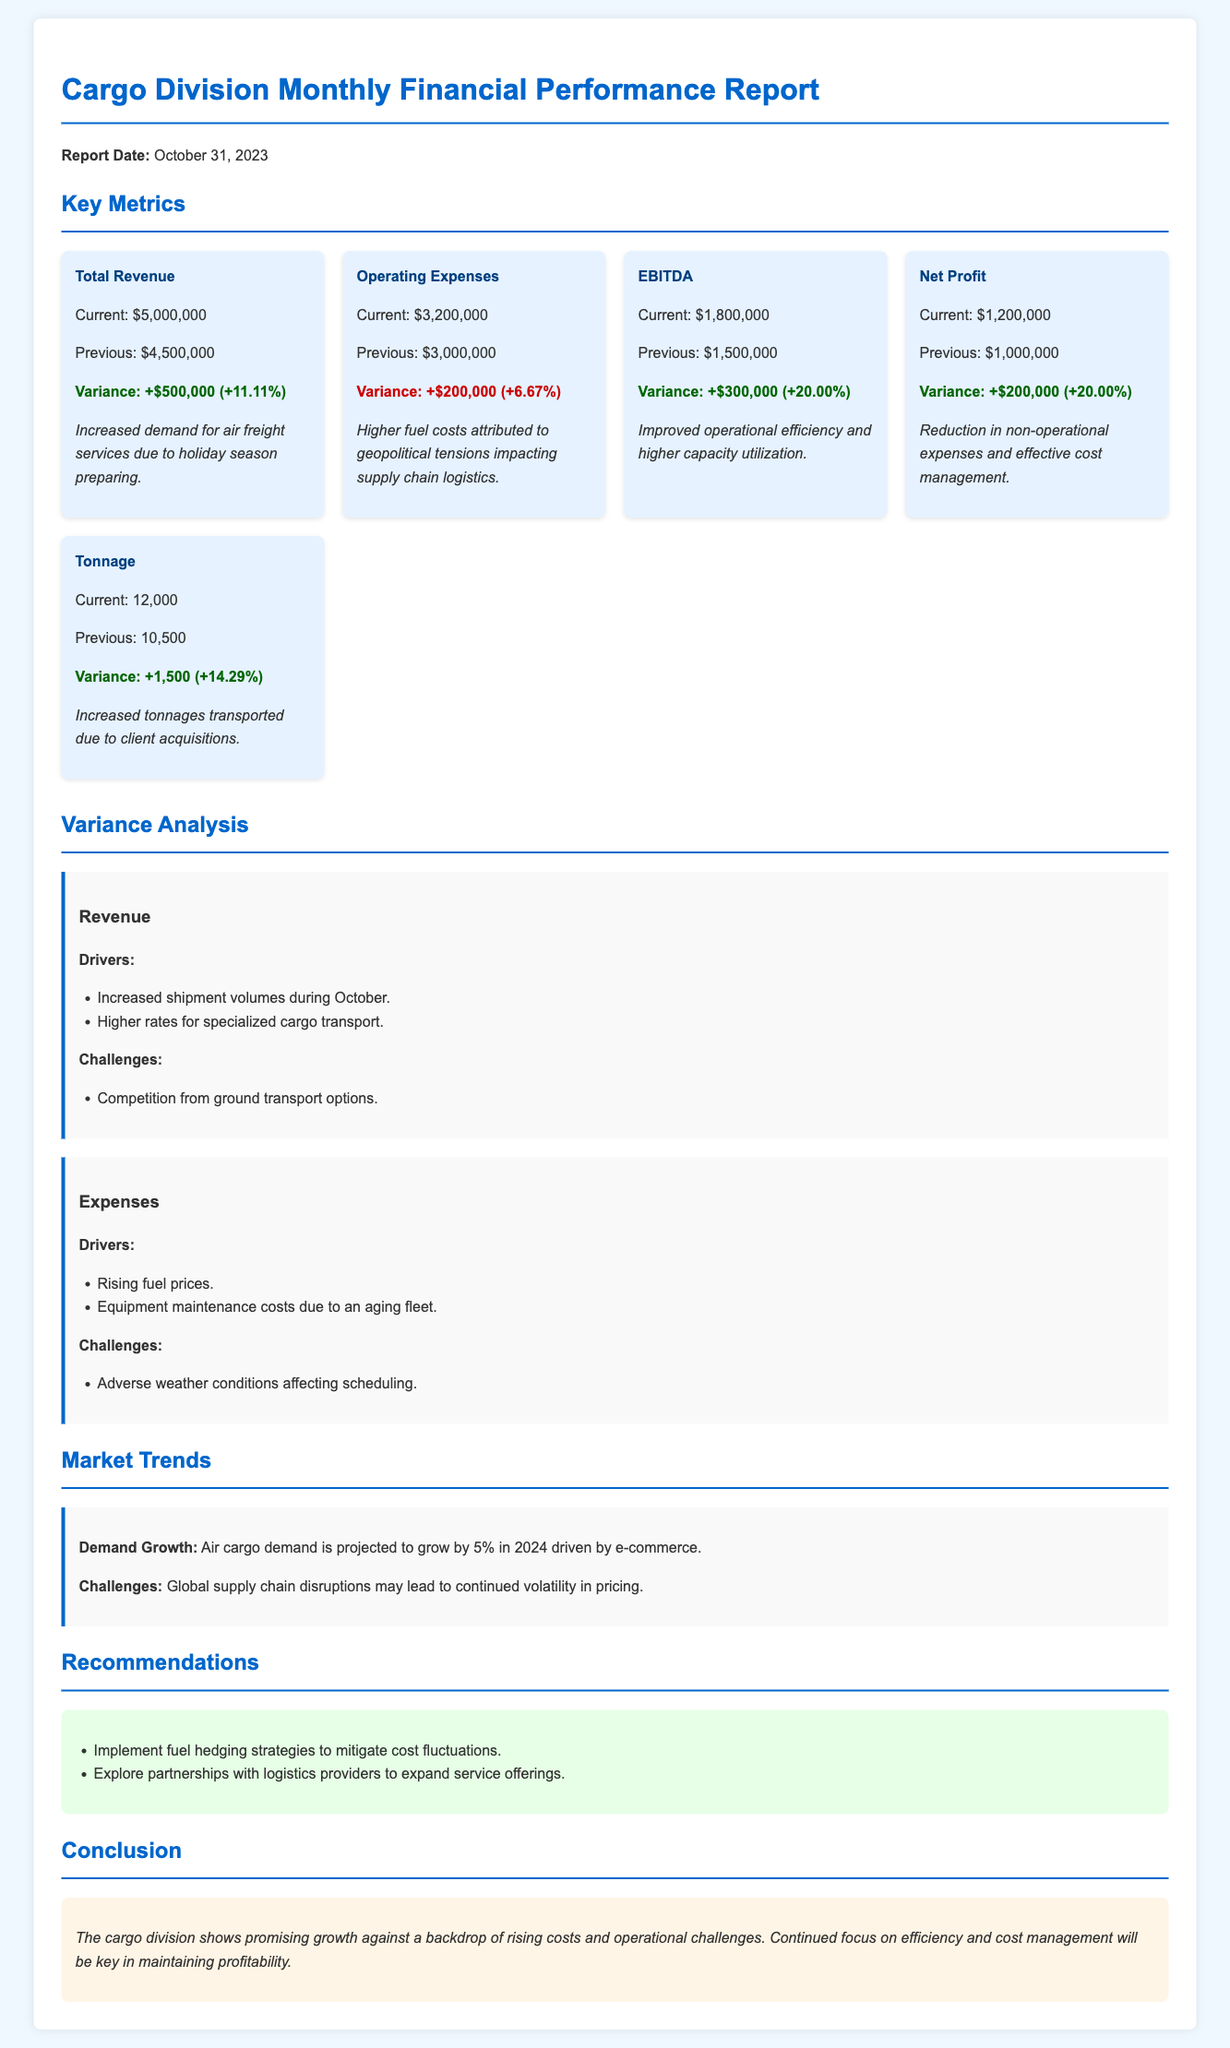what is the total revenue? The total revenue for the cargo division in October 2023, as stated in the document, is $5,000,000.
Answer: $5,000,000 what is the variance for operating expenses? The document shows that operating expenses increased by $200,000 compared to the previous month, which is a variance of +6.67%.
Answer: +$200,000 (+6.67%) what is the current EBITDA? The current EBITDA reported in the document is $1,800,000.
Answer: $1,800,000 what was the previous net profit? According to the document, the previous net profit was $1,000,000.
Answer: $1,000,000 what is the increase in tonnage transported? The document indicates that the tonnage transported increased by 1,500.
Answer: +1,500 what contributed to the increased total revenue? The increase in total revenue was driven by increased shipment volumes and higher rates for specialized cargo transport.
Answer: Increased shipment volumes, higher rates what challenges are mentioned regarding expenses? The document lists adverse weather conditions affecting scheduling as a challenge for expenses.
Answer: Adverse weather conditions what recommendations are provided in the report? The report recommends implementing fuel hedging strategies and exploring partnerships with logistics providers.
Answer: Fuel hedging strategies, partnerships what are the projected market trends for air cargo demand in 2024? The document projects a demand growth of 5% in 2024 driven by e-commerce.
Answer: 5% growth 